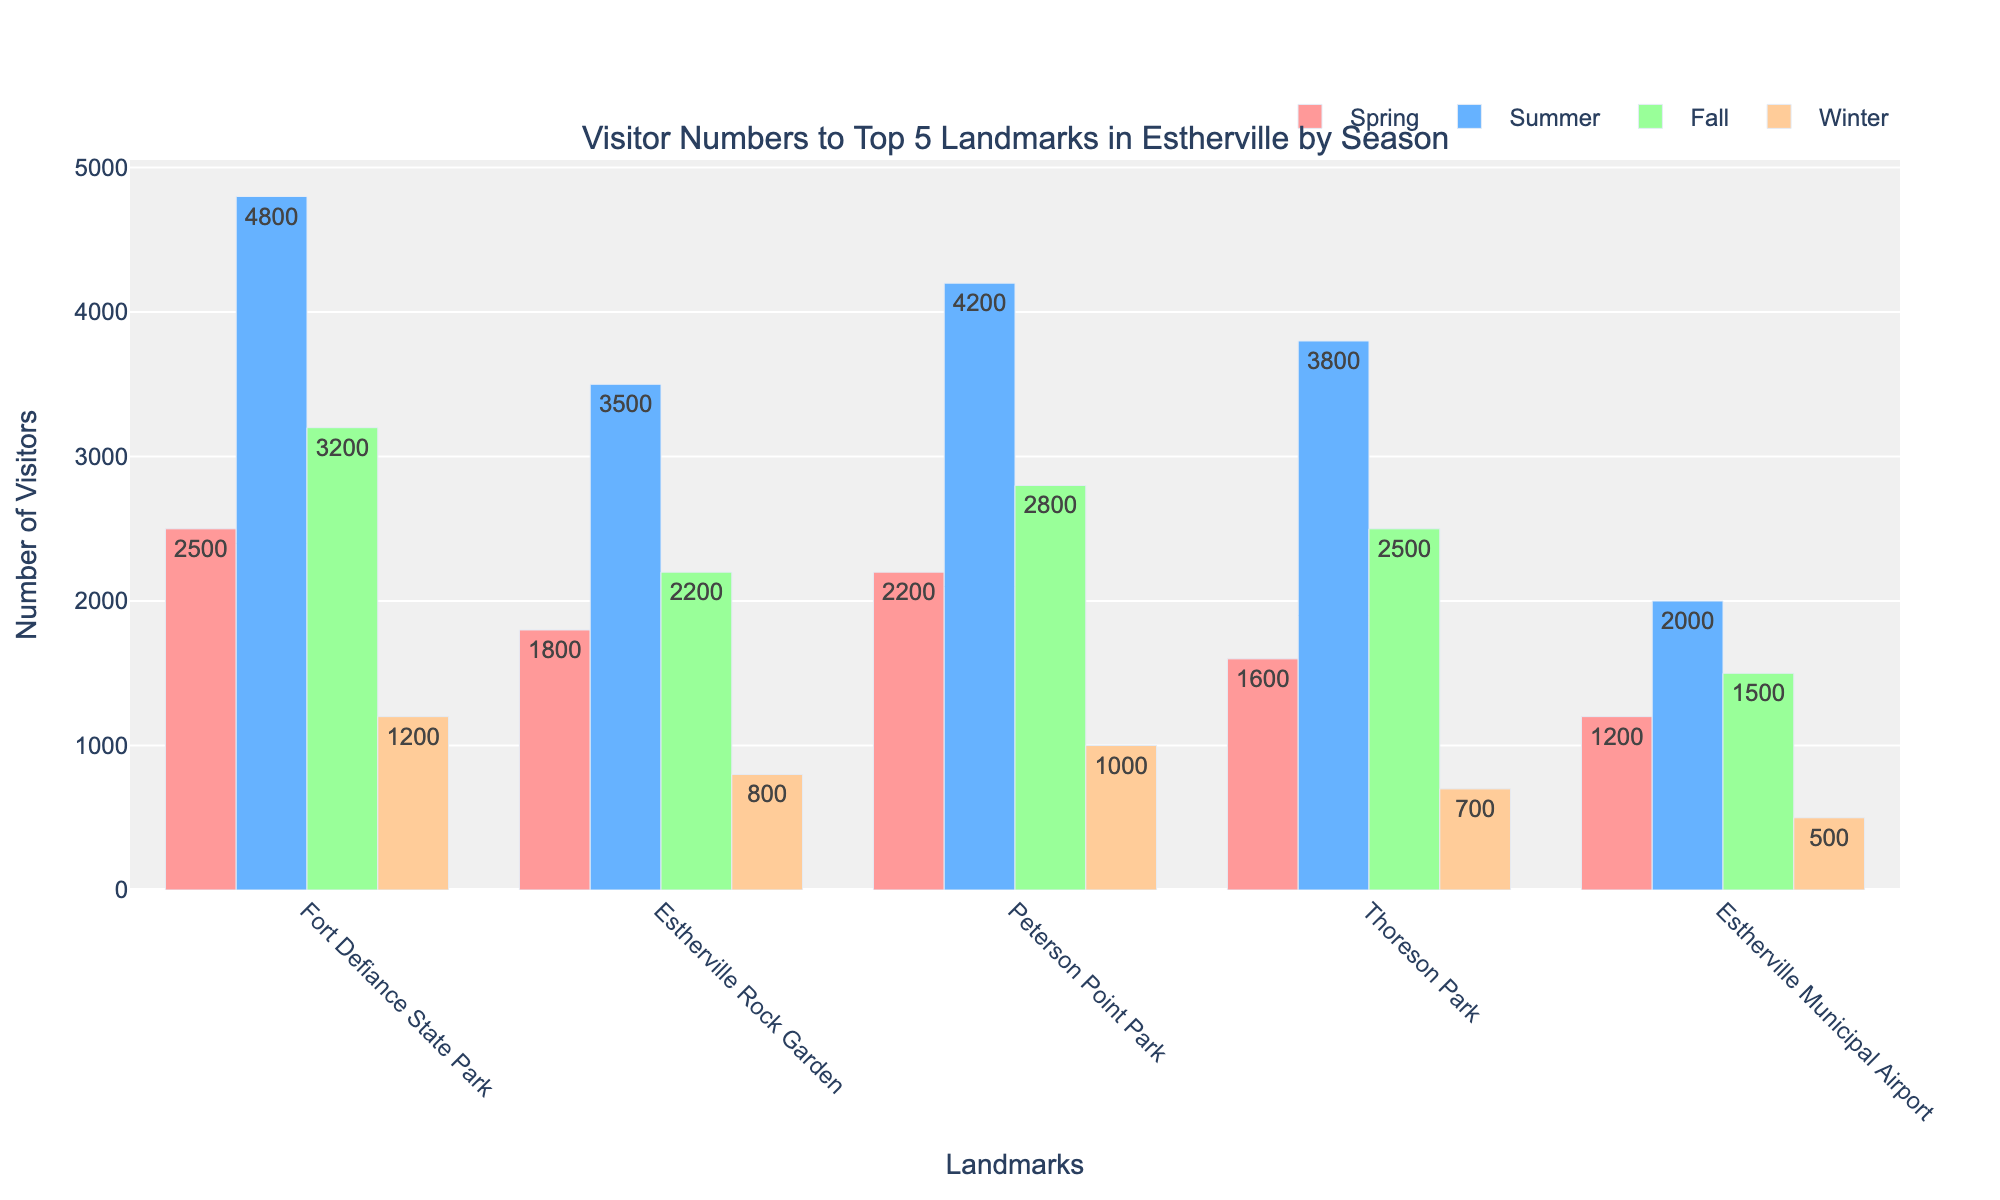What landmark has the highest number of visitors in the summer? The highest bar in the summer section indicates the landmark with the highest number of visitors on the chart. Fort Defiance State Park has the highest bar in the summer season.
Answer: Fort Defiance State Park Which landmark has the lowest number of visitors in winter? Look for the shortest bar in the winter section to find the landmark with the lowest visitor number. Estherville Municipal Airport has the shortest bar in the winter season.
Answer: Estherville Municipal Airport How many total visitors does Peterson Point Park have across all seasons? Add the visitor numbers for Peterson Point Park in all four seasons: Spring (2200) + Summer (4200) + Fall (2800) + Winter (1000).
Answer: 10200 Which season has the most visitors for Thoreson Park, and how many visitors were there? Identify the tallest bar for Thoreson Park. The summer bar is the tallest with 3800 visitors.
Answer: Summer, 3800 Compare the difference in visitor numbers between Estherville Rock Garden in spring and winter. Subtract the winter visitor number of Estherville Rock Garden from the spring visitor number: 1800 (spring) - 800 (winter).
Answer: 1000 Which seasons see more than 3000 visitors to Fort Defiance State Park? Examine the bars for Fort Defiance State Park and check which ones have visitor numbers greater than 3000. Both the summer and fall seasons have over 3000 visitors.
Answer: Summer and Fall What is the average number of visitors to Estherville Municipal Airport across all seasons? Add the visitor numbers for all seasons and divide by the number of seasons: (1200 + 2000 + 1500 + 500) / 4.
Answer: 1300 Compare the visitor numbers in fall between Peterson Point Park and Estherville Rock Garden. Which one has more visitors? Look at the heights of the fall bars for both landmarks and compare them. Peterson Point Park has 2800 visitors, while Estherville Rock Garden has 2200 visitors. Peterson Point Park has more.
Answer: Peterson Point Park Considering all landmarks, which season consistently has the lowest visitor numbers? Identify the shortest bars across all landmarks' seasons. Winter consistently has the lowest visitor numbers among all landmarks.
Answer: Winter If you combine visitor numbers for Spring and Fall for Fort Defiance State Park, do they surpass the Summer visitors? Add the spring and fall visitors: 2500 (spring) + 3200 (fall) = 5700. Compare this to the summer visitors: 4800. Yes, 5700 is greater than 4800.
Answer: Yes 